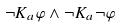<formula> <loc_0><loc_0><loc_500><loc_500>\neg K _ { a } \varphi \wedge \neg K _ { a } \neg \varphi</formula> 